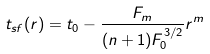<formula> <loc_0><loc_0><loc_500><loc_500>t _ { s f } ( r ) = t _ { 0 } - \frac { F _ { m } } { ( n + 1 ) F _ { 0 } ^ { 3 / 2 } } r ^ { m }</formula> 